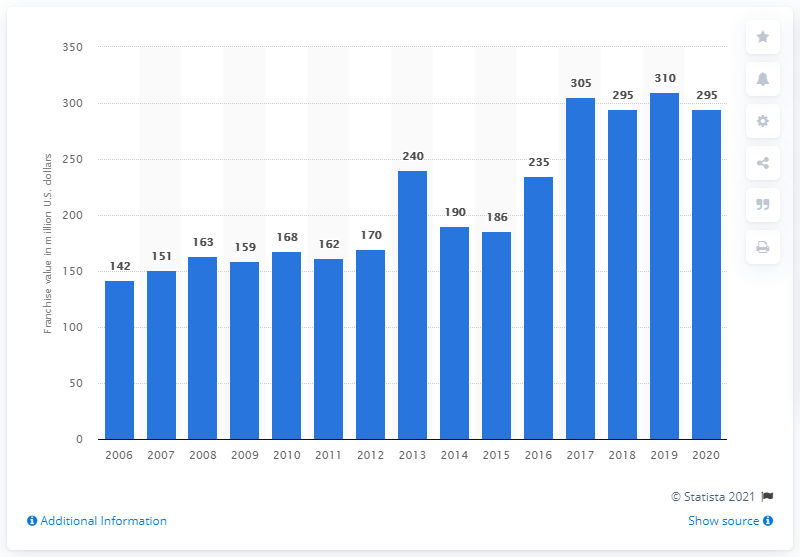Outline some significant characteristics in this image. The value of the Florida Panthers in 2020 was approximately 295 million dollars. 